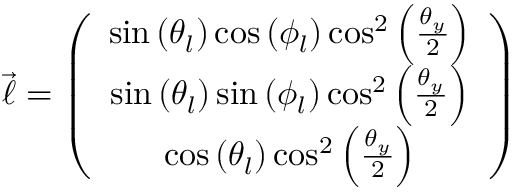<formula> <loc_0><loc_0><loc_500><loc_500>\begin{array} { r } { \overrightarrow { \ell } = \left ( \begin{array} { c } { \sin \left ( \theta _ { l } \right ) \cos \left ( \phi _ { l } \right ) \cos ^ { 2 } \left ( \frac { \theta _ { y } } { 2 } \right ) } \\ { \sin \left ( \theta _ { l } \right ) \sin \left ( \phi _ { l } \right ) \cos ^ { 2 } \left ( \frac { \theta _ { y } } { 2 } \right ) } \\ { \cos \left ( \theta _ { l } \right ) \cos ^ { 2 } \left ( \frac { \theta _ { y } } { 2 } \right ) } \end{array} \right ) } \end{array}</formula> 